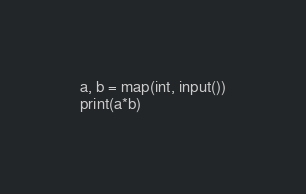<code> <loc_0><loc_0><loc_500><loc_500><_Python_>a, b = map(int, input())
print(a*b)</code> 